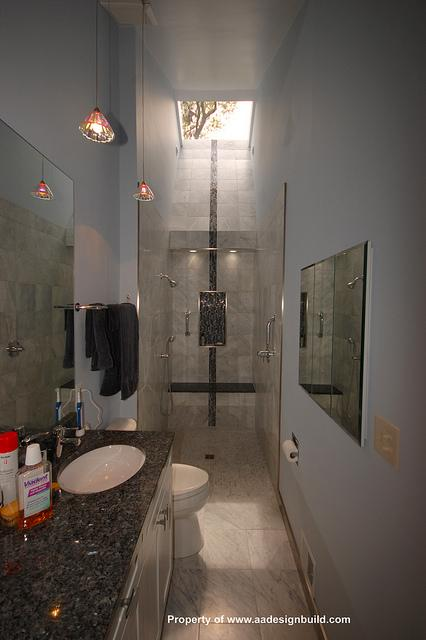What is the item with the white cap used to clean?

Choices:
A) mouth
B) shoes
C) clothes
D) dog hair mouth 